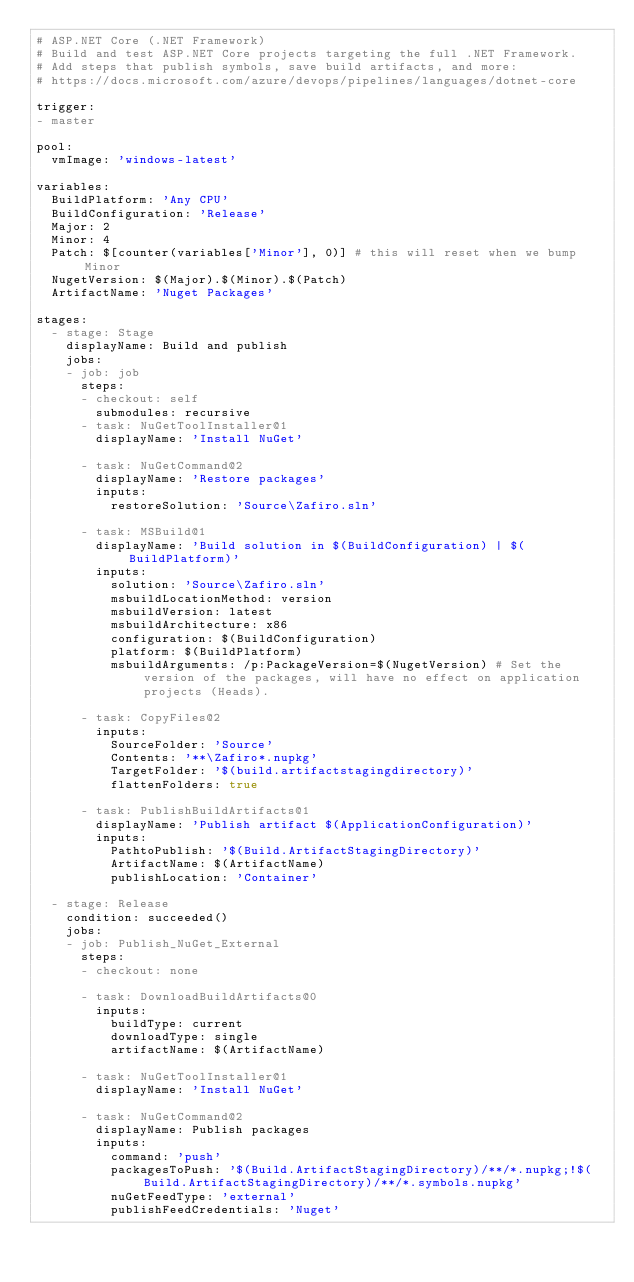Convert code to text. <code><loc_0><loc_0><loc_500><loc_500><_YAML_># ASP.NET Core (.NET Framework)
# Build and test ASP.NET Core projects targeting the full .NET Framework.
# Add steps that publish symbols, save build artifacts, and more:
# https://docs.microsoft.com/azure/devops/pipelines/languages/dotnet-core

trigger:
- master

pool:
  vmImage: 'windows-latest'

variables:
  BuildPlatform: 'Any CPU'
  BuildConfiguration: 'Release'
  Major: 2
  Minor: 4
  Patch: $[counter(variables['Minor'], 0)] # this will reset when we bump Minor
  NugetVersion: $(Major).$(Minor).$(Patch)
  ArtifactName: 'Nuget Packages'

stages:
  - stage: Stage
    displayName: Build and publish
    jobs:
    - job: job
      steps:
      - checkout: self
        submodules: recursive            
      - task: NuGetToolInstaller@1
        displayName: 'Install NuGet'

      - task: NuGetCommand@2
        displayName: 'Restore packages'
        inputs:
          restoreSolution: 'Source\Zafiro.sln'
          
      - task: MSBuild@1
        displayName: 'Build solution in $(BuildConfiguration) | $(BuildPlatform)'
        inputs:
          solution: 'Source\Zafiro.sln'
          msbuildLocationMethod: version
          msbuildVersion: latest
          msbuildArchitecture: x86
          configuration: $(BuildConfiguration)
          platform: $(BuildPlatform)
          msbuildArguments: /p:PackageVersion=$(NugetVersion) # Set the version of the packages, will have no effect on application projects (Heads).
              
      - task: CopyFiles@2
        inputs:
          SourceFolder: 'Source'
          Contents: '**\Zafiro*.nupkg'
          TargetFolder: '$(build.artifactstagingdirectory)'
          flattenFolders: true

      - task: PublishBuildArtifacts@1
        displayName: 'Publish artifact $(ApplicationConfiguration)'
        inputs:
          PathtoPublish: '$(Build.ArtifactStagingDirectory)'
          ArtifactName: $(ArtifactName)
          publishLocation: 'Container'

  - stage: Release
    condition: succeeded()
    jobs:
    - job: Publish_NuGet_External      
      steps:        
      - checkout: none

      - task: DownloadBuildArtifacts@0
        inputs:
          buildType: current
          downloadType: single
          artifactName: $(ArtifactName)

      - task: NuGetToolInstaller@1
        displayName: 'Install NuGet'

      - task: NuGetCommand@2
        displayName: Publish packages
        inputs:
          command: 'push'
          packagesToPush: '$(Build.ArtifactStagingDirectory)/**/*.nupkg;!$(Build.ArtifactStagingDirectory)/**/*.symbols.nupkg'
          nuGetFeedType: 'external'
          publishFeedCredentials: 'Nuget'</code> 